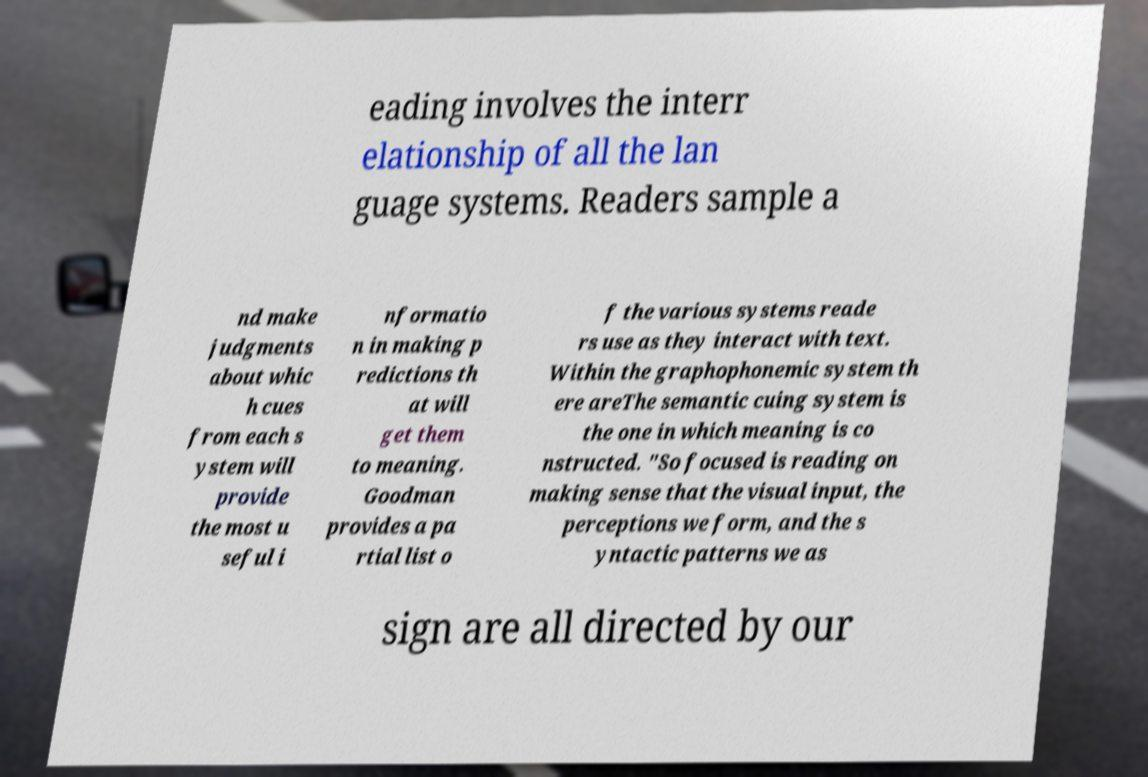Could you extract and type out the text from this image? eading involves the interr elationship of all the lan guage systems. Readers sample a nd make judgments about whic h cues from each s ystem will provide the most u seful i nformatio n in making p redictions th at will get them to meaning. Goodman provides a pa rtial list o f the various systems reade rs use as they interact with text. Within the graphophonemic system th ere areThe semantic cuing system is the one in which meaning is co nstructed. "So focused is reading on making sense that the visual input, the perceptions we form, and the s yntactic patterns we as sign are all directed by our 